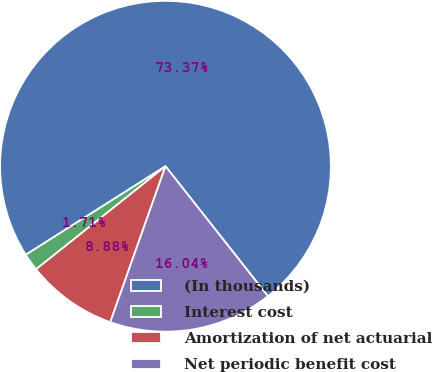<chart> <loc_0><loc_0><loc_500><loc_500><pie_chart><fcel>(In thousands)<fcel>Interest cost<fcel>Amortization of net actuarial<fcel>Net periodic benefit cost<nl><fcel>73.36%<fcel>1.71%<fcel>8.88%<fcel>16.04%<nl></chart> 